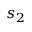<formula> <loc_0><loc_0><loc_500><loc_500>s _ { 2 }</formula> 